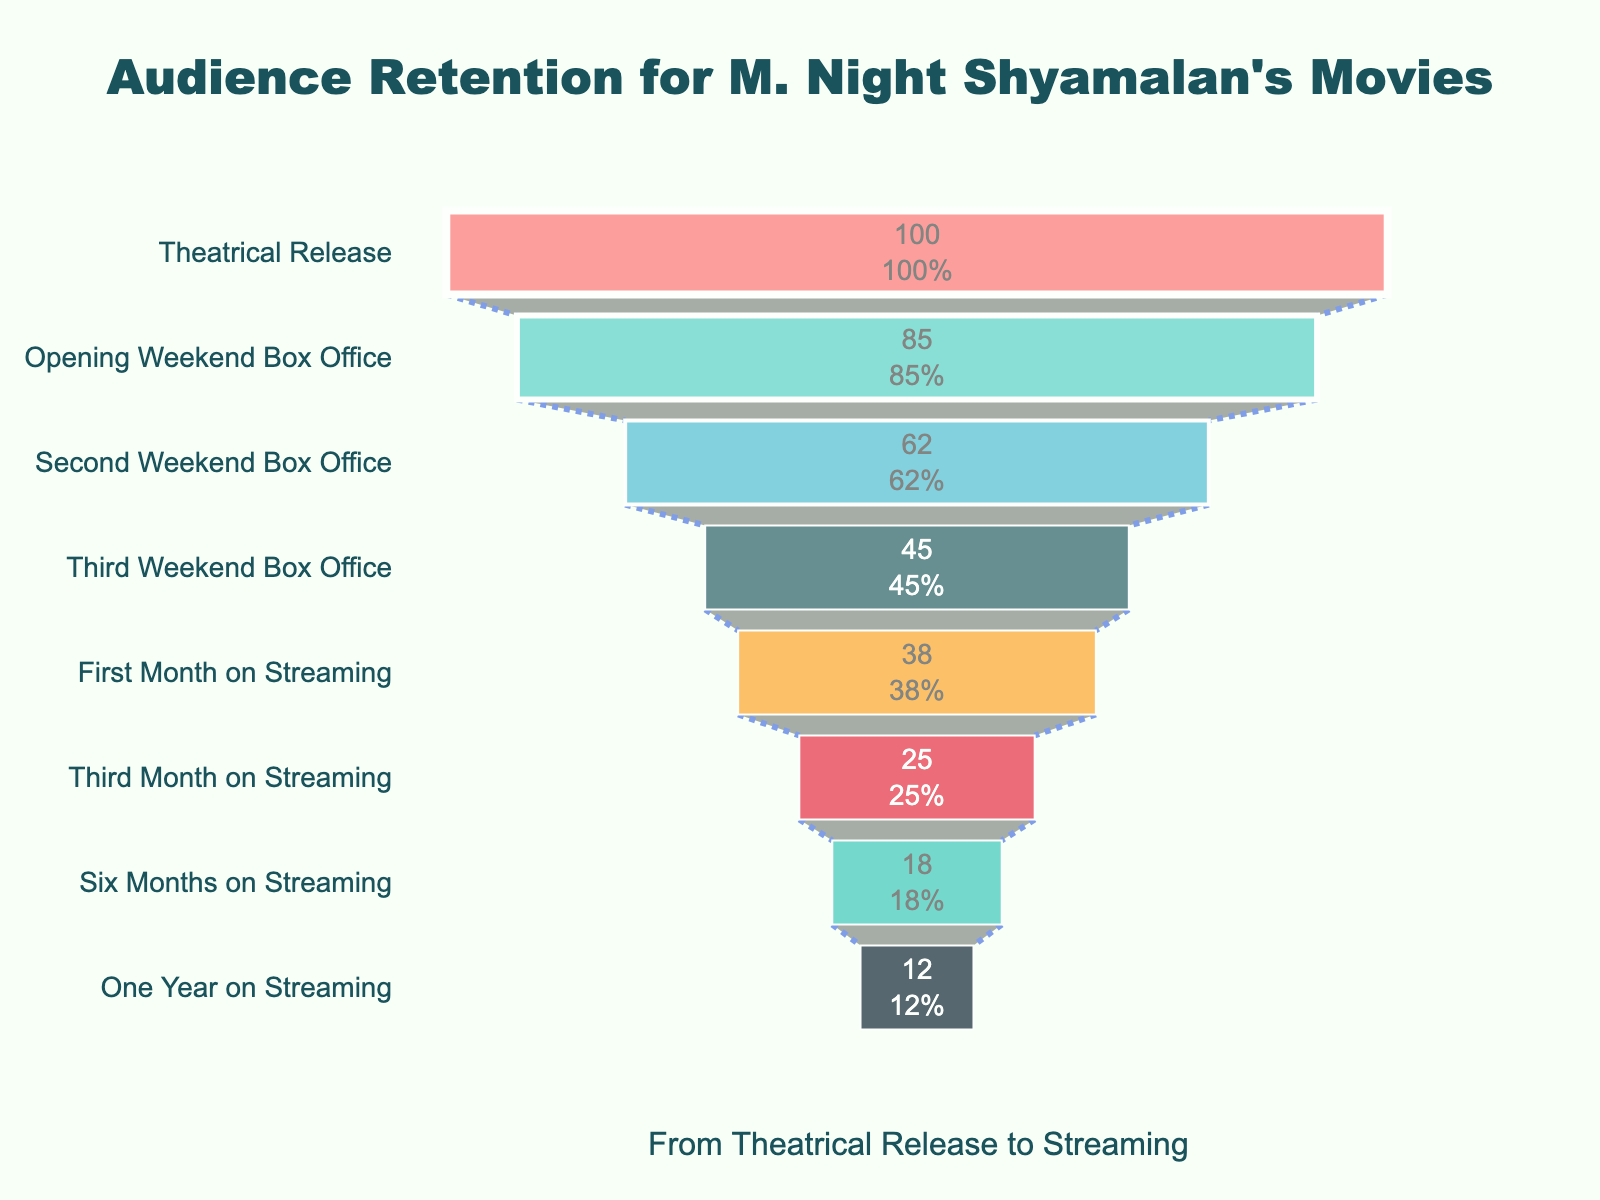What is the retention rate during the Opening Weekend Box Office? The Opening Weekend Box Office retention rate is directly labeled on the figure. It is shown as 85%.
Answer: 85% By how much does the retention rate decrease from Theatrical Release to Third Weekend Box Office? The retention rate at Theatrical Release is 100%, and at Third Weekend Box Office it is 45%. The decrease is calculated by subtracting 45 from 100.
Answer: 55% What is the percentage retention decrease from the First Month on Streaming to Six Months on Streaming? The retention rate in the First Month on Streaming is 38%, and at Six Months on Streaming, it is 18%. The percentage decrease is ((38 - 18) / 38) * 100.
Answer: 52.63% Compare the retention between Second Weekend Box Office and Third Month on Streaming. Which stage has a higher retention rate? Second Weekend Box Office retention rate is 62%, and Third Month on Streaming is 25%. 62% is higher than 25%.
Answer: Second Weekend Box Office Which retention stage shows the most significant drop in percentage from its previous stage? By analyzing the drop between each stage: 
- Theatrical Release to Opening Weekend Box Office: 15%
- Opening Weekend Box Office to Second Weekend Box Office: 23%
- Second Weekend Box Office to Third Weekend Box Office: 17%
- Third Weekend Box Office to First Month on Streaming: 7%
- First Month on Streaming to Third Month on Streaming: 13%
- Third Month on Streaming to Six Months on Streaming: 7%
- Six Months on Streaming to One Year on Streaming: 6%
The largest drop is between Opening Weekend Box Office to Second Weekend Box Office at 23%.
Answer: Opening Weekend Box Office to Second Weekend Box Office Approximately what fraction of the initial audience remains after one year on streaming? The retention rate after one year on streaming is 12%. This is 12 out of 100, which simplifies to about 3/25.
Answer: 3/25 Which stages retain more than half of the audience from the previous stage? Reviewing the decreases:
- Theatrical Release to Opening Weekend Box Office: 15% (> 50%)
- Opening Weekend Box Office to Second Weekend Box Office: 23% (≤ 50%)
- Second Weekend Box Office to Third Weekend Box Office: 17% (> 50%)
- Third Weekend Box Office to First Month on Streaming: 7% (> 50%)
- First Month on Streaming to Third Month on Streaming: 13% (> 50%)
- Third Month on Streaming to Six Months on Streaming: 7% (> 50%)
- Six Months on Streaming to One Year on Streaming: 6% (> 50%)
Only "Opening Weekend Box Office to Second Weekend Box Office" retains less than half. The rest retain more than half.
Answer: Theatrical Release to Opening Weekend Box Office, Second Weekend Box Office to Third Weekend Box Office, Third Weekend Box Office to First Month on Streaming, First Month on Streaming to Third Month on Streaming, Third Month on Streaming to Six Months on Streaming, Six Months on Streaming to One Year on Streaming What are the retention rates for the first three months on streaming? The retention rates are directly labeled on the figure for the relevant stages:
- First Month on Streaming: 38%
- Third Month on Streaming: 25%
- Six Months on Streaming: 18%
Answer: 38%, 25%, 18% At which stage does the audience retention rate first drop below 50%? By checking the retention rates:
- Theatrical Release: 100%
- Opening Weekend Box Office: 85%
- Second Weekend Box Office: 62%
- Third Weekend Box Office: 45%
The rate first drops below 50% at the Third Weekend Box Office stage.
Answer: Third Weekend Box Office 